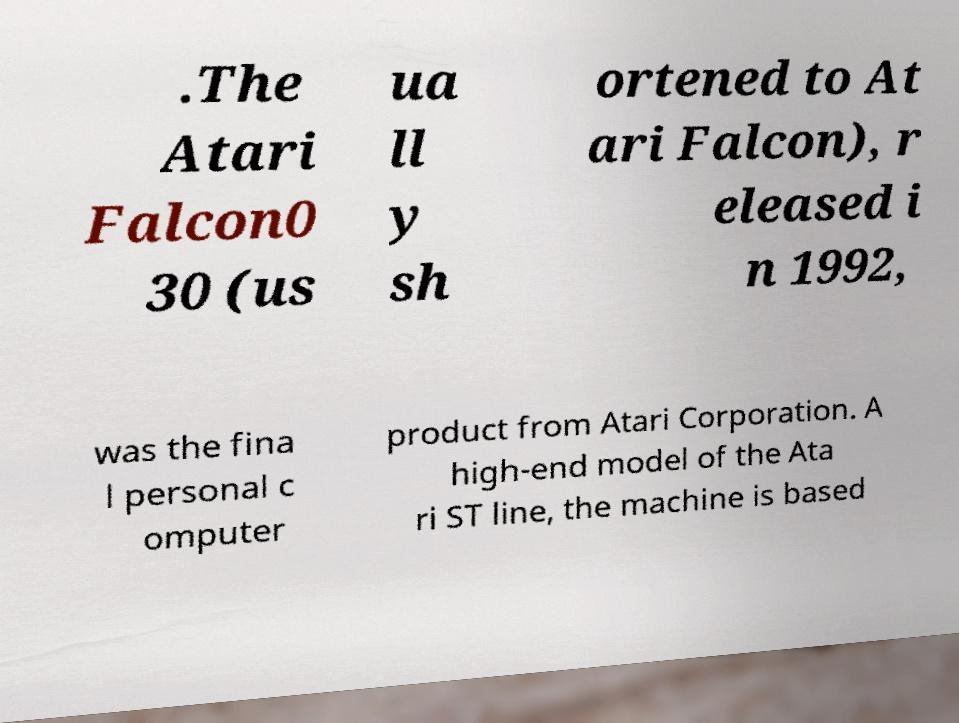There's text embedded in this image that I need extracted. Can you transcribe it verbatim? .The Atari Falcon0 30 (us ua ll y sh ortened to At ari Falcon), r eleased i n 1992, was the fina l personal c omputer product from Atari Corporation. A high-end model of the Ata ri ST line, the machine is based 